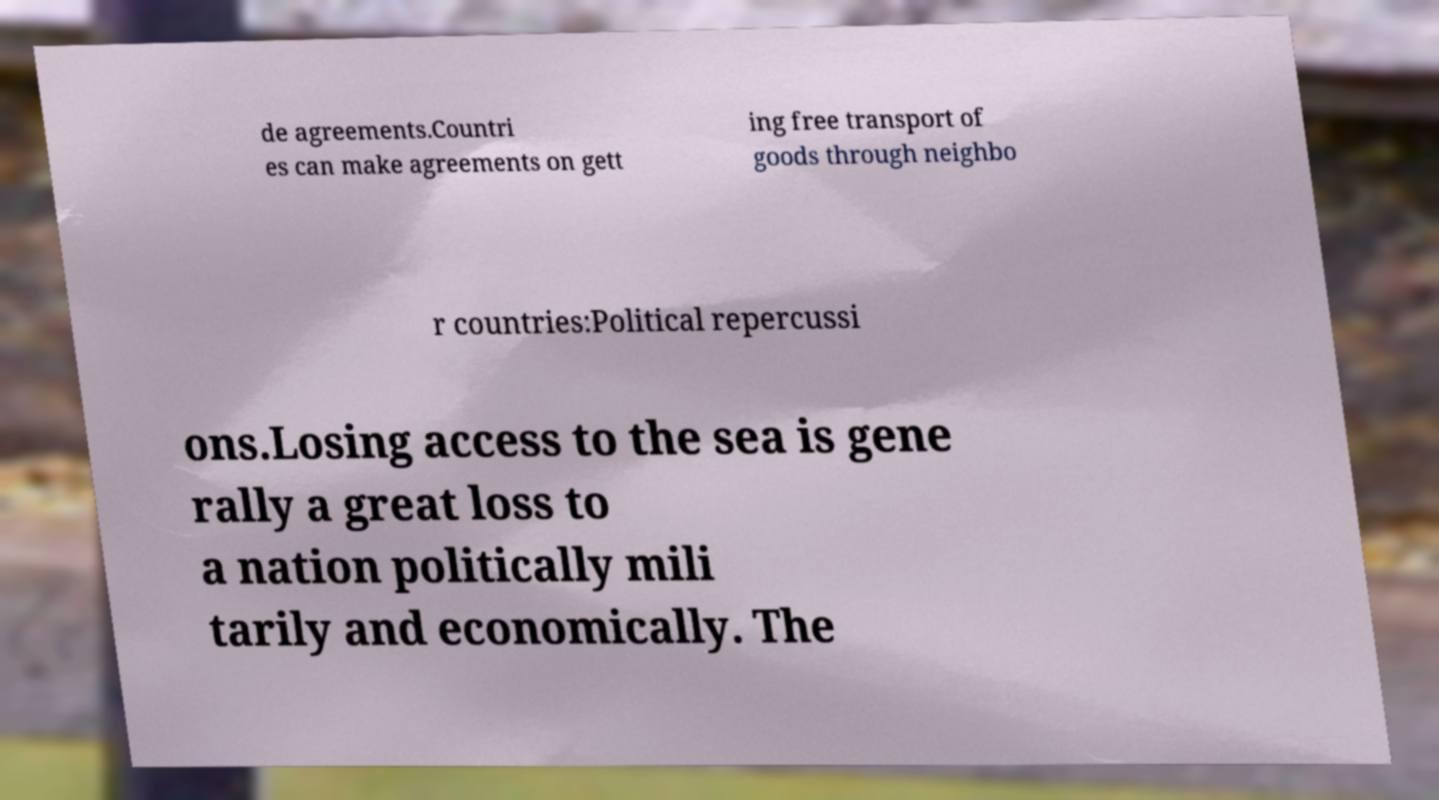Please read and relay the text visible in this image. What does it say? de agreements.Countri es can make agreements on gett ing free transport of goods through neighbo r countries:Political repercussi ons.Losing access to the sea is gene rally a great loss to a nation politically mili tarily and economically. The 